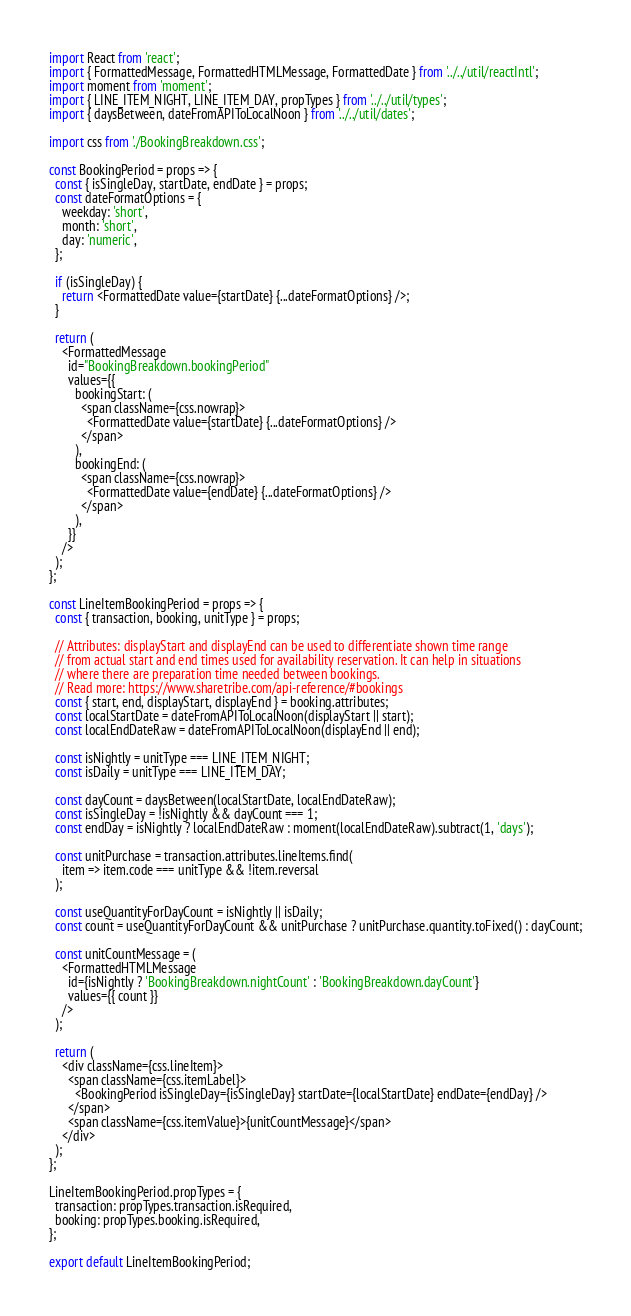<code> <loc_0><loc_0><loc_500><loc_500><_JavaScript_>import React from 'react';
import { FormattedMessage, FormattedHTMLMessage, FormattedDate } from '../../util/reactIntl';
import moment from 'moment';
import { LINE_ITEM_NIGHT, LINE_ITEM_DAY, propTypes } from '../../util/types';
import { daysBetween, dateFromAPIToLocalNoon } from '../../util/dates';

import css from './BookingBreakdown.css';

const BookingPeriod = props => {
  const { isSingleDay, startDate, endDate } = props;
  const dateFormatOptions = {
    weekday: 'short',
    month: 'short',
    day: 'numeric',
  };

  if (isSingleDay) {
    return <FormattedDate value={startDate} {...dateFormatOptions} />;
  }

  return (
    <FormattedMessage
      id="BookingBreakdown.bookingPeriod"
      values={{
        bookingStart: (
          <span className={css.nowrap}>
            <FormattedDate value={startDate} {...dateFormatOptions} />
          </span>
        ),
        bookingEnd: (
          <span className={css.nowrap}>
            <FormattedDate value={endDate} {...dateFormatOptions} />
          </span>
        ),
      }}
    />
  );
};

const LineItemBookingPeriod = props => {
  const { transaction, booking, unitType } = props;

  // Attributes: displayStart and displayEnd can be used to differentiate shown time range
  // from actual start and end times used for availability reservation. It can help in situations
  // where there are preparation time needed between bookings.
  // Read more: https://www.sharetribe.com/api-reference/#bookings
  const { start, end, displayStart, displayEnd } = booking.attributes;
  const localStartDate = dateFromAPIToLocalNoon(displayStart || start);
  const localEndDateRaw = dateFromAPIToLocalNoon(displayEnd || end);

  const isNightly = unitType === LINE_ITEM_NIGHT;
  const isDaily = unitType === LINE_ITEM_DAY;

  const dayCount = daysBetween(localStartDate, localEndDateRaw);
  const isSingleDay = !isNightly && dayCount === 1;
  const endDay = isNightly ? localEndDateRaw : moment(localEndDateRaw).subtract(1, 'days');

  const unitPurchase = transaction.attributes.lineItems.find(
    item => item.code === unitType && !item.reversal
  );

  const useQuantityForDayCount = isNightly || isDaily;
  const count = useQuantityForDayCount && unitPurchase ? unitPurchase.quantity.toFixed() : dayCount;

  const unitCountMessage = (
    <FormattedHTMLMessage
      id={isNightly ? 'BookingBreakdown.nightCount' : 'BookingBreakdown.dayCount'}
      values={{ count }}
    />
  );

  return (
    <div className={css.lineItem}>
      <span className={css.itemLabel}>
        <BookingPeriod isSingleDay={isSingleDay} startDate={localStartDate} endDate={endDay} />
      </span>
      <span className={css.itemValue}>{unitCountMessage}</span>
    </div>
  );
};

LineItemBookingPeriod.propTypes = {
  transaction: propTypes.transaction.isRequired,
  booking: propTypes.booking.isRequired,
};

export default LineItemBookingPeriod;
</code> 